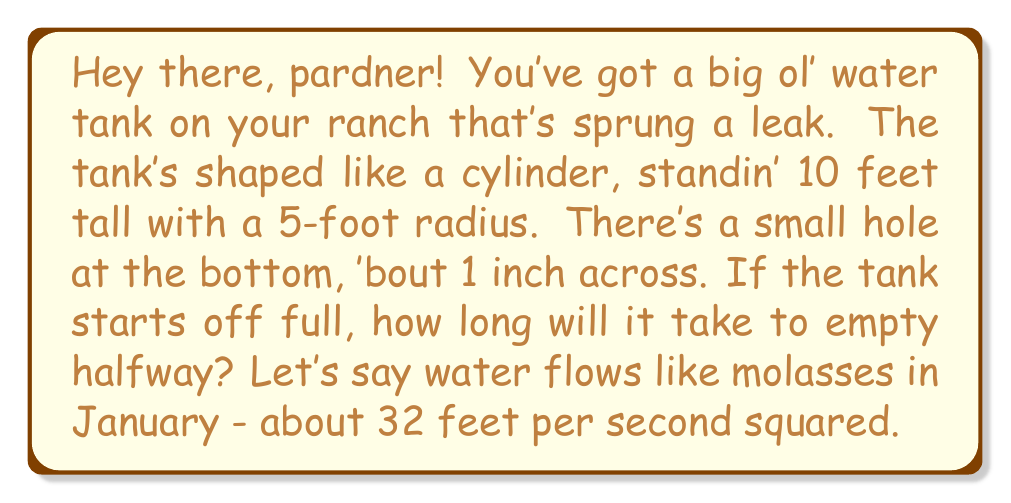What is the answer to this math problem? Alright, cowboy, let's wrangle this problem:

1) First, we need to use Torricelli's law. It's fancy talk for how fast water leaves a hole:

   $$ v = \sqrt{2gh} $$

   Where $v$ is the speed of the water, $g$ is how fast things fall (32 ft/s²), and $h$ is how high the water is.

2) Now, the rate the water level drops depends on how much water's leavin' and how wide the tank is:

   $$ \frac{dh}{dt} = -\frac{a}{A}\sqrt{2gh} $$

   $a$ is the size of the hole, and $A$ is how wide the tank is.

3) Let's round up our numbers:
   - Tank radius (R) = 5 ft
   - Hole radius (r) = 0.5 inches = 0.5/12 = 1/24 ft
   - $g$ = 32 ft/s²

4) We can work out $A$ and $a$:
   $A = \pi R^2 = \pi \cdot 5^2 = 25\pi$ sq ft
   $a = \pi r^2 = \pi \cdot (1/24)^2 = \pi/576$ sq ft

5) Now our equation looks like:

   $$ \frac{dh}{dt} = -\frac{\pi/576}{25\pi}\sqrt{2 \cdot 32 \cdot h} = -\frac{1}{3600}\sqrt{64h} = -\frac{8}{3600}\sqrt{h} $$

6) To solve this, we need to separate and integrate:

   $$ \int_{10}^5 \frac{dh}{\sqrt{h}} = -\frac{8}{3600}\int_0^t dt $$

7) Solving the left side:

   $$ 2\sqrt{h}\bigg|_{10}^5 = 2(\sqrt{5} - \sqrt{10}) = 2\sqrt{5}(1 - \sqrt{2}) $$

8) And the right side:

   $$ -\frac{8}{3600}t $$

9) Putting it together:

   $$ 2\sqrt{5}(1 - \sqrt{2}) = -\frac{8}{3600}t $$

10) Solving for $t$:

    $$ t = \frac{2\sqrt{5}(1 - \sqrt{2}) \cdot 3600}{8} \approx 447.21 $$
Answer: It'll take about 447 seconds, or roughly 7 minutes and 27 seconds, for that tank to empty halfway. 